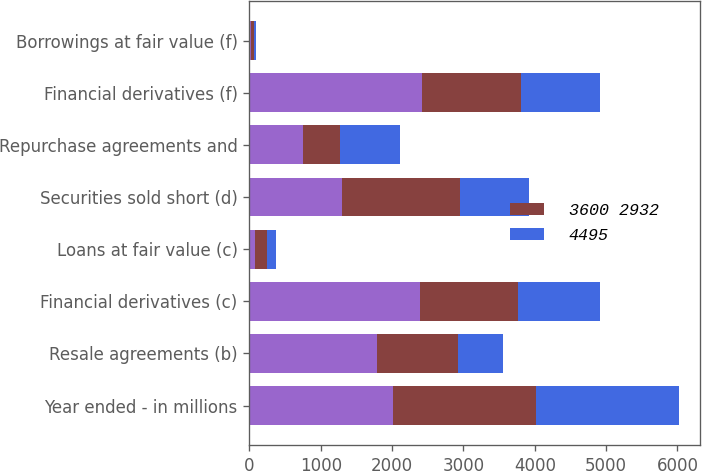Convert chart. <chart><loc_0><loc_0><loc_500><loc_500><stacked_bar_chart><ecel><fcel>Year ended - in millions<fcel>Resale agreements (b)<fcel>Financial derivatives (c)<fcel>Loans at fair value (c)<fcel>Securities sold short (d)<fcel>Repurchase agreements and<fcel>Financial derivatives (f)<fcel>Borrowings at fair value (f)<nl><fcel>nan<fcel>2008<fcel>1794<fcel>2389<fcel>83<fcel>1294<fcel>756<fcel>2423<fcel>22<nl><fcel>3600 2932<fcel>2007<fcel>1133<fcel>1378<fcel>166<fcel>1657<fcel>520<fcel>1384<fcel>39<nl><fcel>4495<fcel>2006<fcel>623<fcel>1148<fcel>128<fcel>965<fcel>833<fcel>1103<fcel>31<nl></chart> 